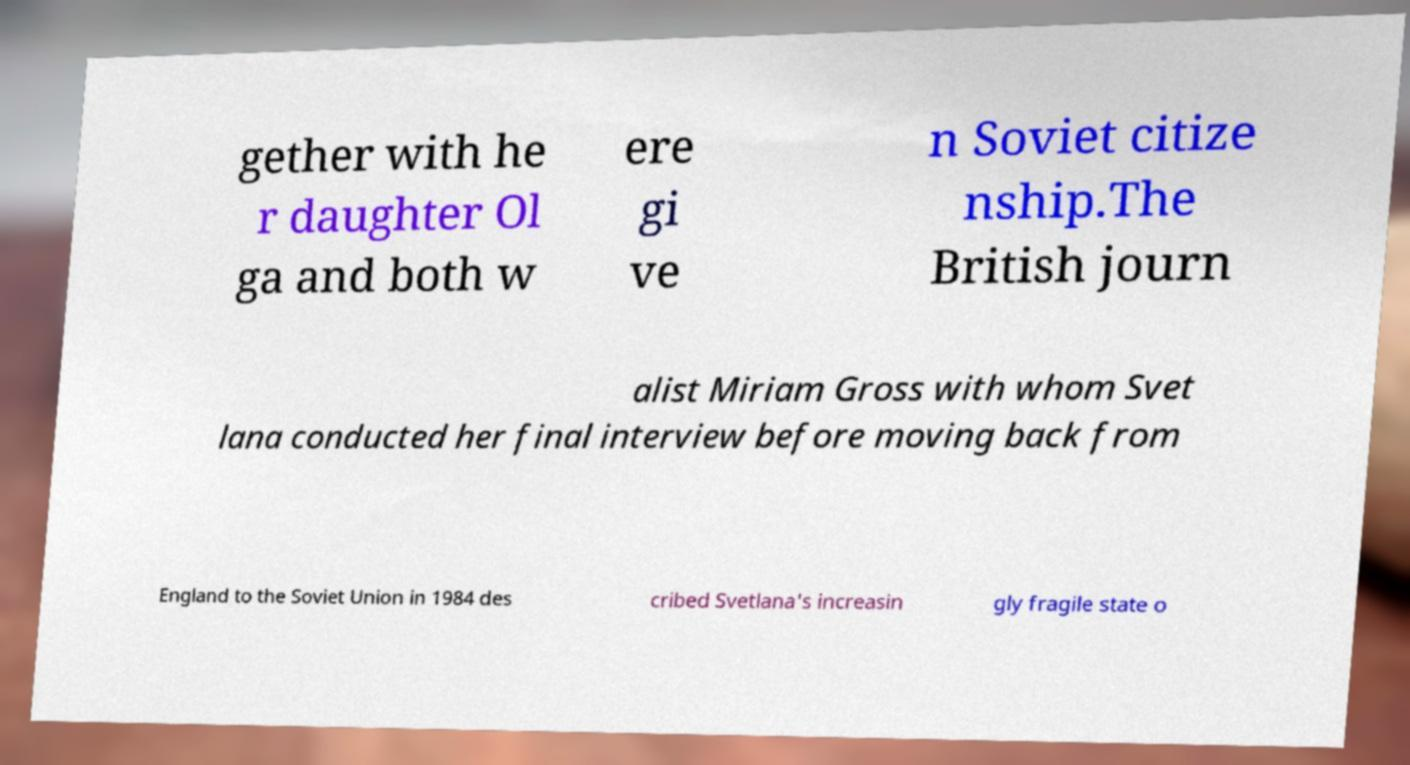Can you read and provide the text displayed in the image?This photo seems to have some interesting text. Can you extract and type it out for me? gether with he r daughter Ol ga and both w ere gi ve n Soviet citize nship.The British journ alist Miriam Gross with whom Svet lana conducted her final interview before moving back from England to the Soviet Union in 1984 des cribed Svetlana's increasin gly fragile state o 